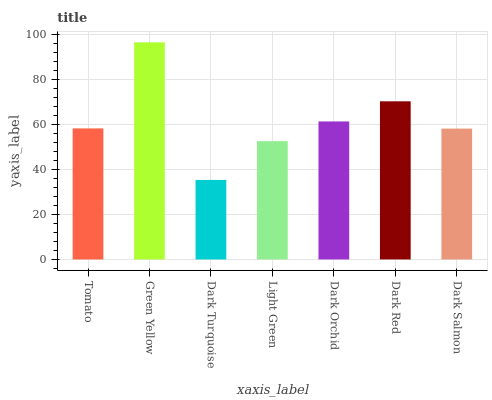Is Dark Turquoise the minimum?
Answer yes or no. Yes. Is Green Yellow the maximum?
Answer yes or no. Yes. Is Green Yellow the minimum?
Answer yes or no. No. Is Dark Turquoise the maximum?
Answer yes or no. No. Is Green Yellow greater than Dark Turquoise?
Answer yes or no. Yes. Is Dark Turquoise less than Green Yellow?
Answer yes or no. Yes. Is Dark Turquoise greater than Green Yellow?
Answer yes or no. No. Is Green Yellow less than Dark Turquoise?
Answer yes or no. No. Is Tomato the high median?
Answer yes or no. Yes. Is Tomato the low median?
Answer yes or no. Yes. Is Dark Turquoise the high median?
Answer yes or no. No. Is Light Green the low median?
Answer yes or no. No. 